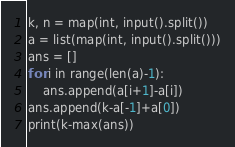Convert code to text. <code><loc_0><loc_0><loc_500><loc_500><_Python_>k, n = map(int, input().split())
a = list(map(int, input().split()))
ans = []
for i in range(len(a)-1):
    ans.append(a[i+1]-a[i])
ans.append(k-a[-1]+a[0])
print(k-max(ans))

</code> 